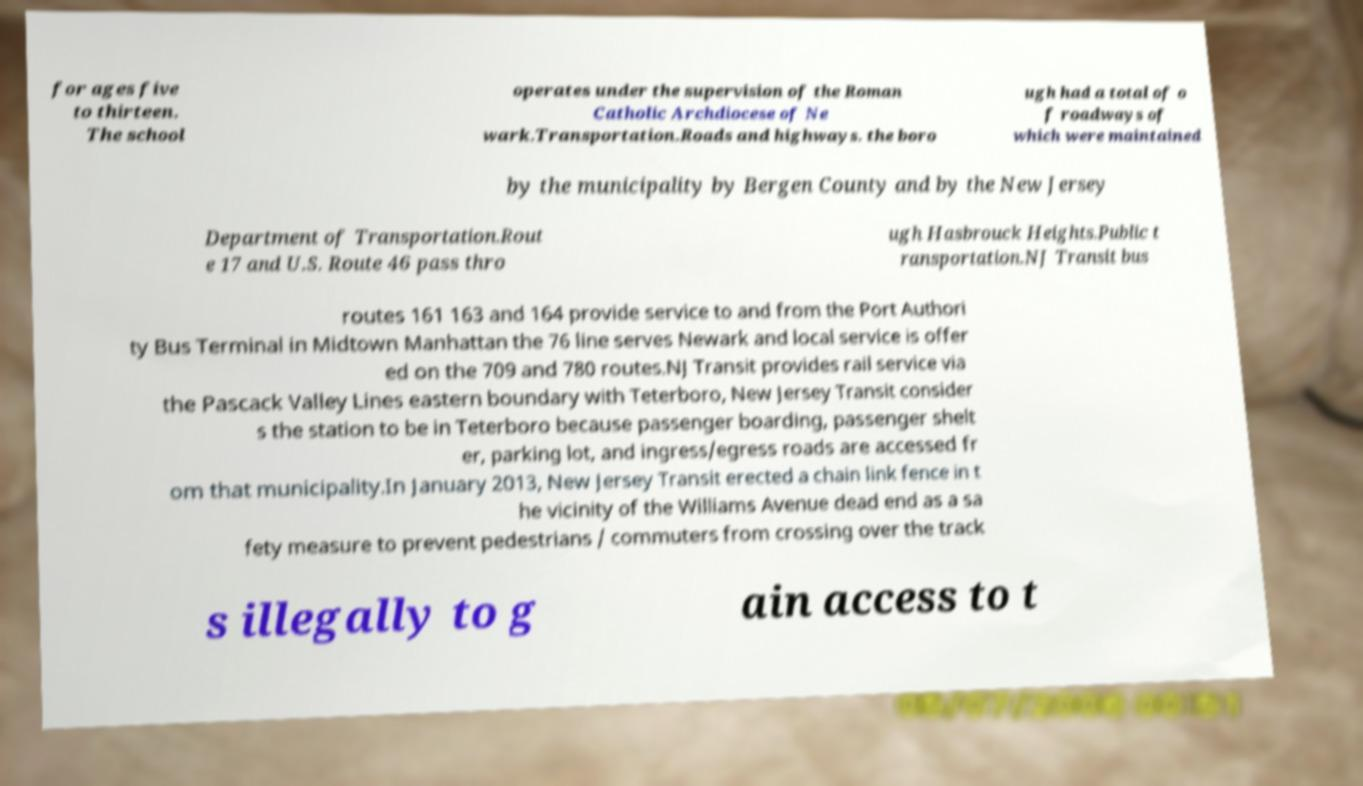Could you extract and type out the text from this image? for ages five to thirteen. The school operates under the supervision of the Roman Catholic Archdiocese of Ne wark.Transportation.Roads and highways. the boro ugh had a total of o f roadways of which were maintained by the municipality by Bergen County and by the New Jersey Department of Transportation.Rout e 17 and U.S. Route 46 pass thro ugh Hasbrouck Heights.Public t ransportation.NJ Transit bus routes 161 163 and 164 provide service to and from the Port Authori ty Bus Terminal in Midtown Manhattan the 76 line serves Newark and local service is offer ed on the 709 and 780 routes.NJ Transit provides rail service via the Pascack Valley Lines eastern boundary with Teterboro, New Jersey Transit consider s the station to be in Teterboro because passenger boarding, passenger shelt er, parking lot, and ingress/egress roads are accessed fr om that municipality.In January 2013, New Jersey Transit erected a chain link fence in t he vicinity of the Williams Avenue dead end as a sa fety measure to prevent pedestrians / commuters from crossing over the track s illegally to g ain access to t 